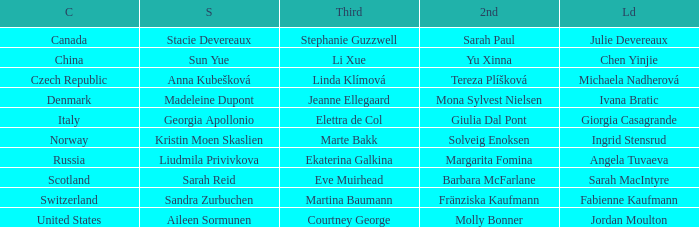Could you parse the entire table as a dict? {'header': ['C', 'S', 'Third', '2nd', 'Ld'], 'rows': [['Canada', 'Stacie Devereaux', 'Stephanie Guzzwell', 'Sarah Paul', 'Julie Devereaux'], ['China', 'Sun Yue', 'Li Xue', 'Yu Xinna', 'Chen Yinjie'], ['Czech Republic', 'Anna Kubešková', 'Linda Klímová', 'Tereza Plíšková', 'Michaela Nadherová'], ['Denmark', 'Madeleine Dupont', 'Jeanne Ellegaard', 'Mona Sylvest Nielsen', 'Ivana Bratic'], ['Italy', 'Georgia Apollonio', 'Elettra de Col', 'Giulia Dal Pont', 'Giorgia Casagrande'], ['Norway', 'Kristin Moen Skaslien', 'Marte Bakk', 'Solveig Enoksen', 'Ingrid Stensrud'], ['Russia', 'Liudmila Privivkova', 'Ekaterina Galkina', 'Margarita Fomina', 'Angela Tuvaeva'], ['Scotland', 'Sarah Reid', 'Eve Muirhead', 'Barbara McFarlane', 'Sarah MacIntyre'], ['Switzerland', 'Sandra Zurbuchen', 'Martina Baumann', 'Fränziska Kaufmann', 'Fabienne Kaufmann'], ['United States', 'Aileen Sormunen', 'Courtney George', 'Molly Bonner', 'Jordan Moulton']]} What is the second that has jordan moulton as the lead? Molly Bonner. 